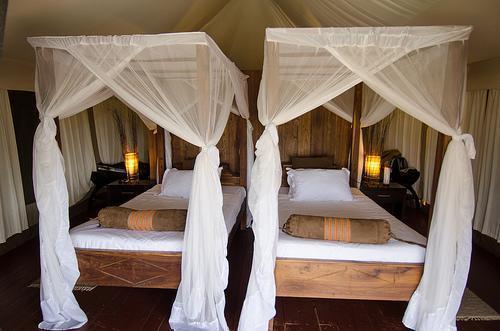How many beds are pictured?
Give a very brief answer. 2. How many sheets are touching the floor?
Give a very brief answer. 4. How many doorways are pictured?
Give a very brief answer. 1. 